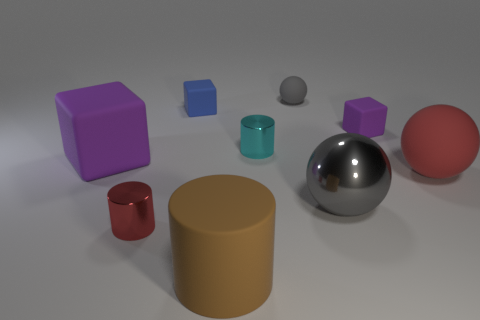Is there a tiny ball of the same color as the matte cylinder?
Your answer should be very brief. No. Are any tiny green things visible?
Offer a very short reply. No. Is the large gray metal thing the same shape as the gray rubber object?
Your response must be concise. Yes. What number of tiny objects are either cyan cylinders or rubber objects?
Your response must be concise. 4. The big block is what color?
Keep it short and to the point. Purple. There is a purple thing in front of the purple thing that is on the right side of the small gray matte sphere; what shape is it?
Provide a succinct answer. Cube. Is there a tiny gray ball made of the same material as the large block?
Your answer should be compact. Yes. There is a gray rubber sphere behind the red shiny object; is it the same size as the big purple thing?
Your response must be concise. No. What number of purple objects are either small matte things or small matte spheres?
Ensure brevity in your answer.  1. What is the tiny cube that is on the left side of the tiny purple object made of?
Your answer should be compact. Rubber. 